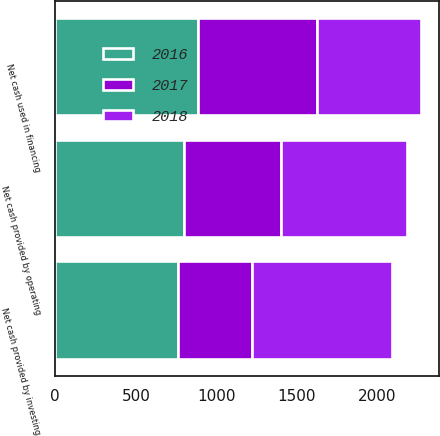Convert chart. <chart><loc_0><loc_0><loc_500><loc_500><stacked_bar_chart><ecel><fcel>Net cash provided by operating<fcel>Net cash provided by investing<fcel>Net cash used in financing<nl><fcel>2017<fcel>603<fcel>463<fcel>737<nl><fcel>2016<fcel>797<fcel>760.5<fcel>884<nl><fcel>2018<fcel>784<fcel>864<fcel>647<nl></chart> 